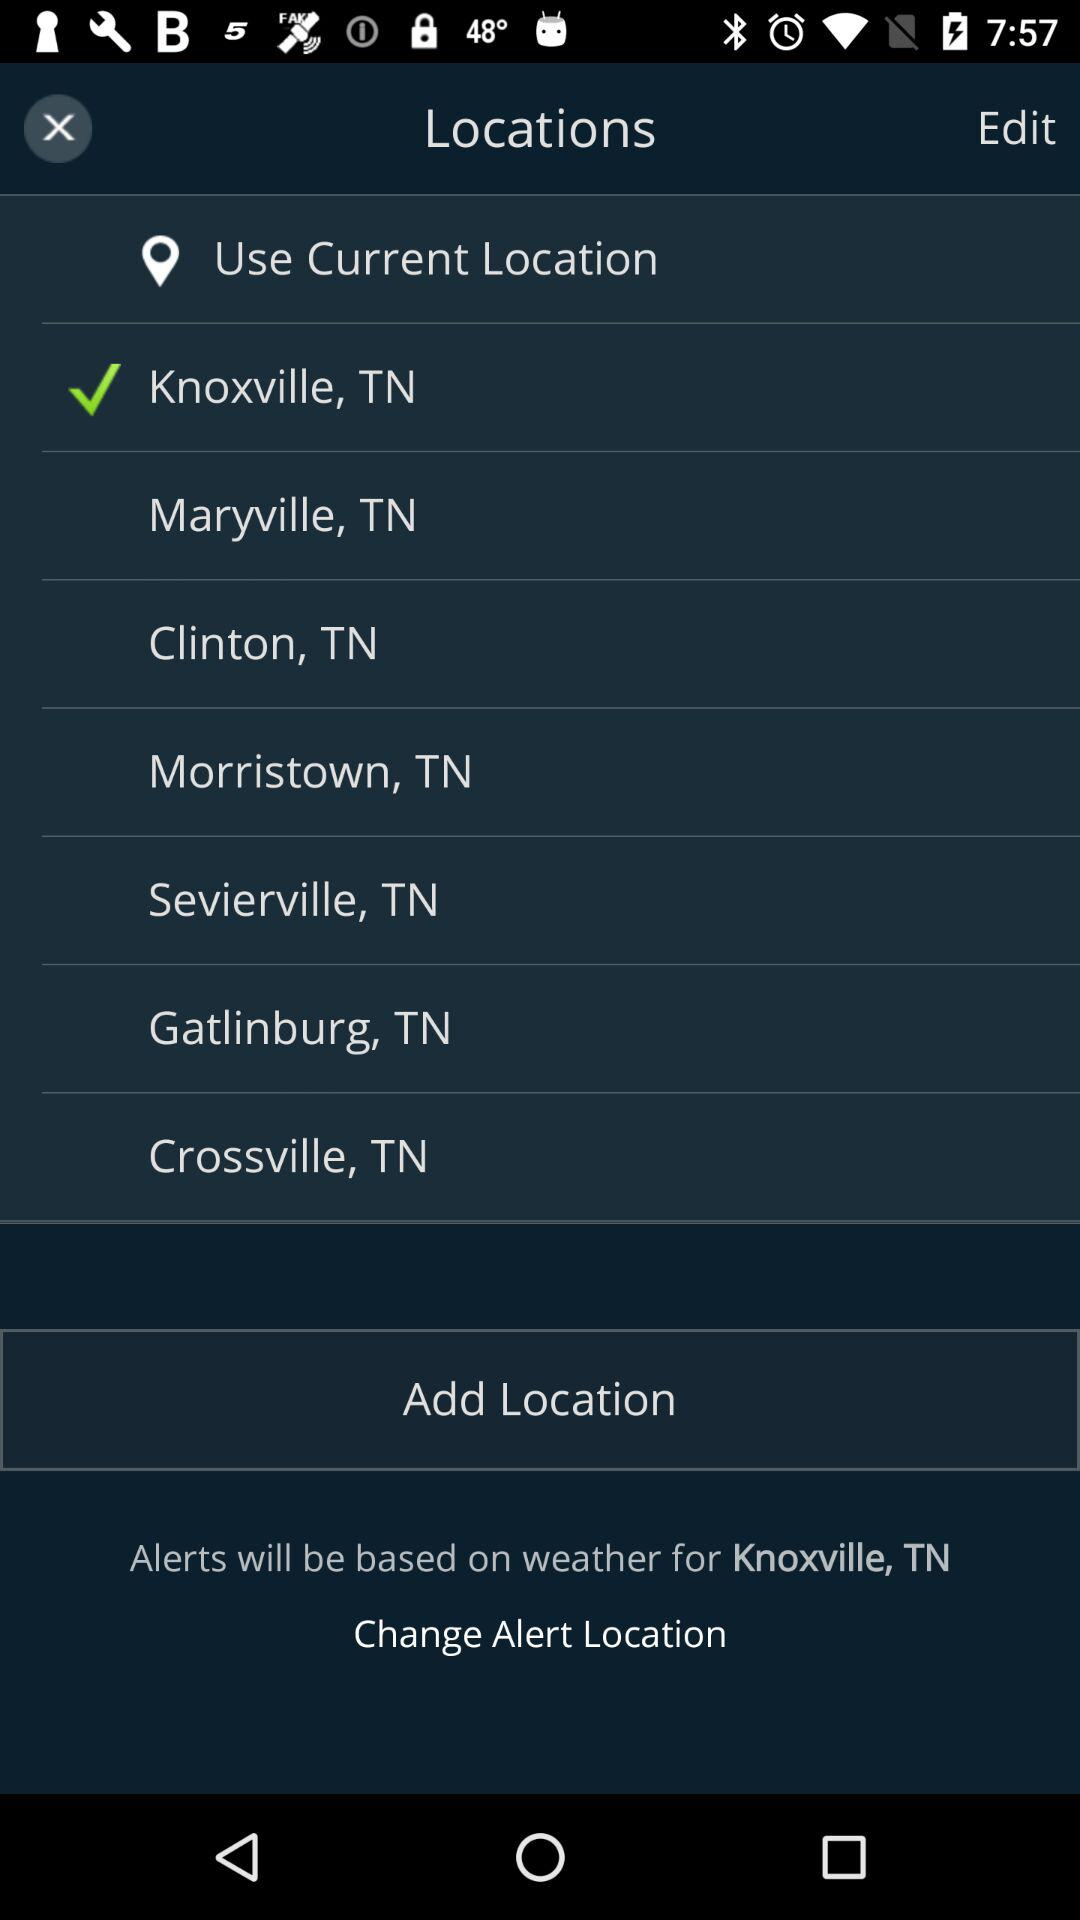What is the selected location? The selected location is Knoxville, TN. 